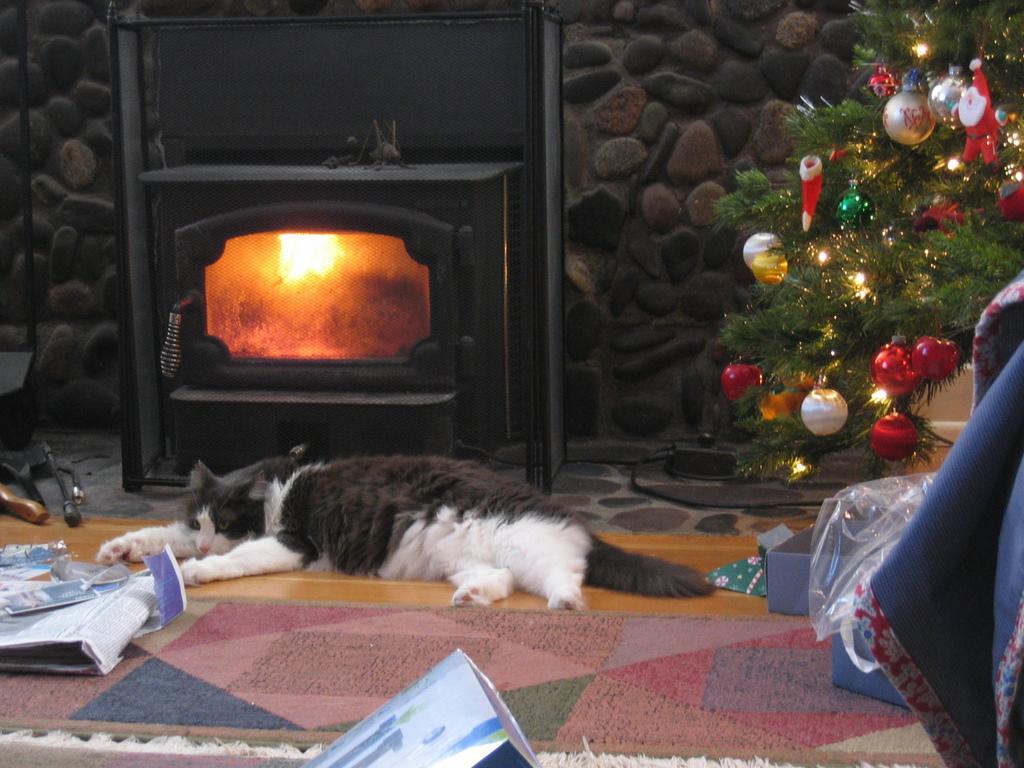Could you give a brief overview of what you see in this image? In this picture we can see a cat lying on the path. There is a carpet on the floor. We can see a file, newspaper, cover and other objects on the path. There is a Christmas tree. We can see a few lights and decorative balls on this Christmas tree. There is a chimney and fire is visible inside the chimney. 